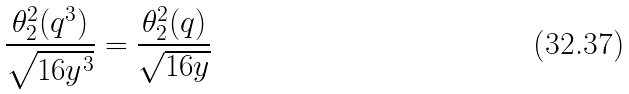Convert formula to latex. <formula><loc_0><loc_0><loc_500><loc_500>\frac { \theta _ { 2 } ^ { 2 } ( q ^ { 3 } ) } { \sqrt { 1 6 y ^ { 3 } } } = \frac { \theta _ { 2 } ^ { 2 } ( q ) } { \sqrt { 1 6 y } }</formula> 